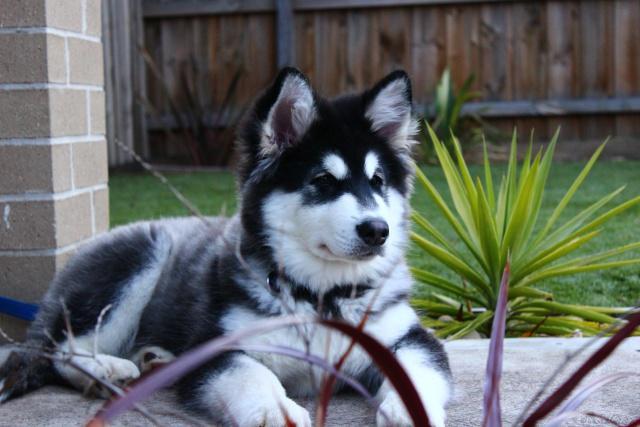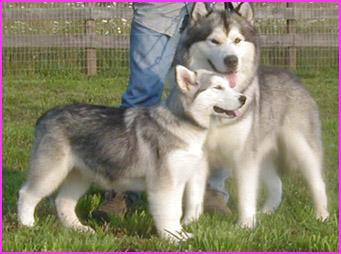The first image is the image on the left, the second image is the image on the right. For the images displayed, is the sentence "There are less than 4 dogs" factually correct? Answer yes or no. Yes. The first image is the image on the left, the second image is the image on the right. Examine the images to the left and right. Is the description "The right image contains at least two dogs." accurate? Answer yes or no. Yes. 